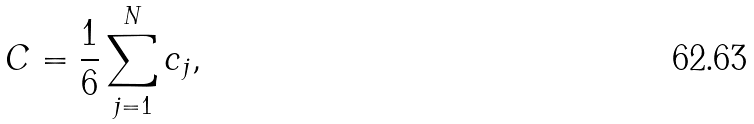Convert formula to latex. <formula><loc_0><loc_0><loc_500><loc_500>C = \frac { 1 } { 6 } \sum _ { j = 1 } ^ { N } c _ { j } ,</formula> 